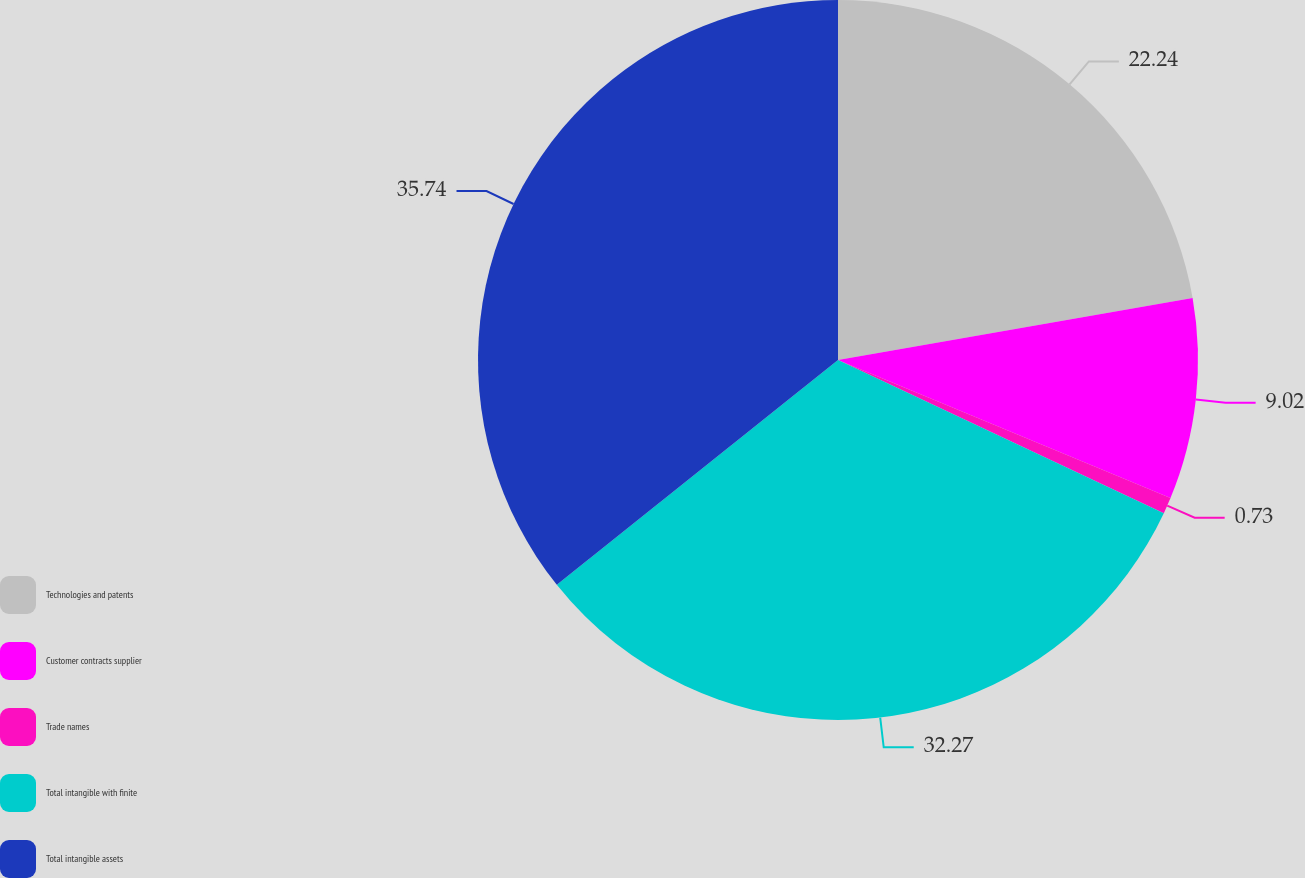Convert chart. <chart><loc_0><loc_0><loc_500><loc_500><pie_chart><fcel>Technologies and patents<fcel>Customer contracts supplier<fcel>Trade names<fcel>Total intangible with finite<fcel>Total intangible assets<nl><fcel>22.24%<fcel>9.02%<fcel>0.73%<fcel>32.27%<fcel>35.73%<nl></chart> 